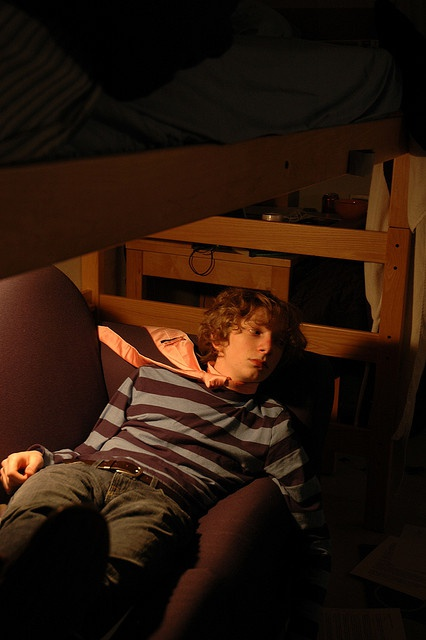Describe the objects in this image and their specific colors. I can see bed in black tones, people in black, maroon, and gray tones, couch in black, maroon, orange, and red tones, tie in black, orange, red, and maroon tones, and bowl in black, maroon, and gray tones in this image. 